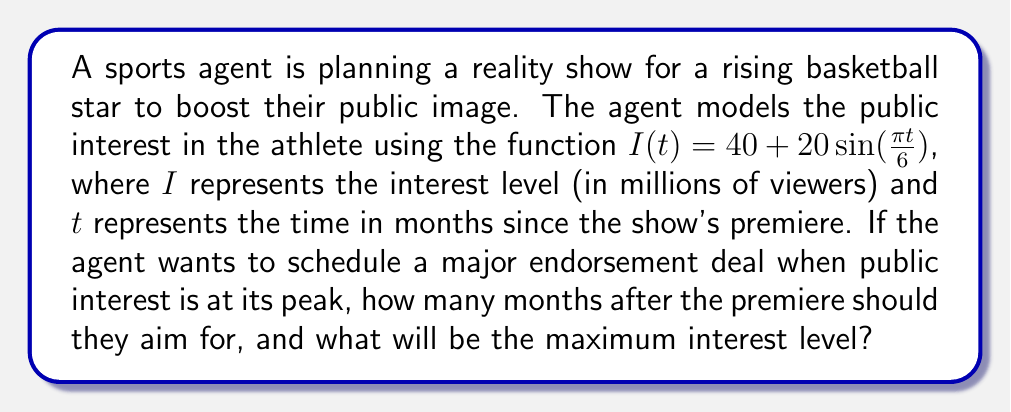Teach me how to tackle this problem. To solve this problem, we need to analyze the periodic function given:

1) The function is of the form $I(t) = A + B\sin(\omega t)$, where:
   $A = 40$ (the midline of the function)
   $B = 20$ (the amplitude)
   $\omega = \frac{\pi}{6}$ (the angular frequency)

2) The period of this function is:
   $T = \frac{2\pi}{\omega} = \frac{2\pi}{\frac{\pi}{6}} = 12$ months

3) The function will reach its maximum when $\sin(\frac{\pi t}{6}) = 1$, which occurs when:
   $\frac{\pi t}{6} = \frac{\pi}{2} + 2\pi n$, where $n$ is any integer

4) Solving for $t$:
   $t = 3 + 12n$ months, where $n$ is any integer

5) The first peak (smallest positive $t$) occurs when $n = 0$, so $t = 3$ months

6) The maximum interest level will be:
   $I_{max} = A + B = 40 + 20 = 60$ million viewers

Therefore, the agent should aim for 3 months after the premiere, and the maximum interest level will be 60 million viewers.
Answer: 3 months; 60 million viewers 